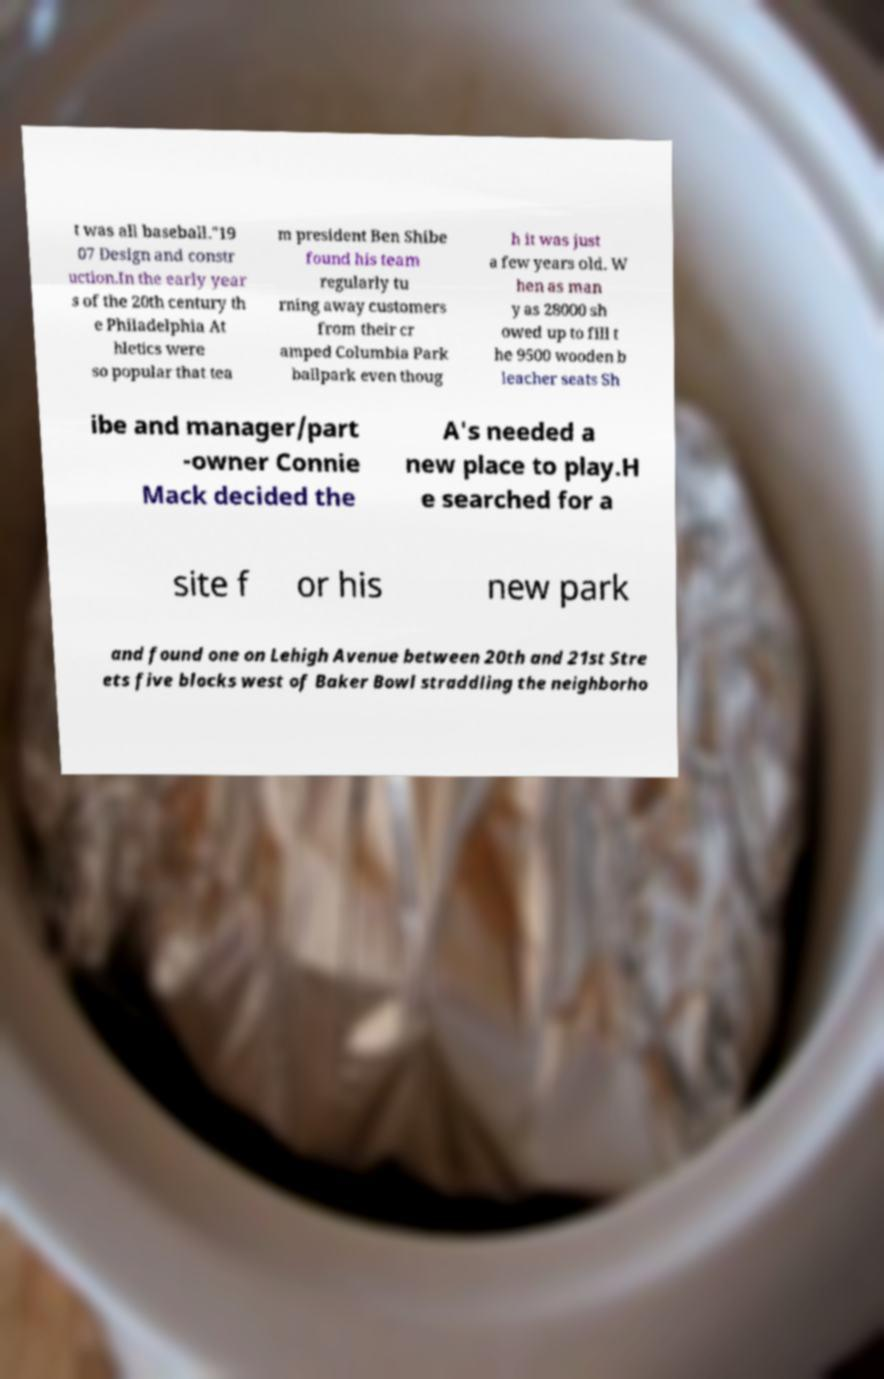Could you assist in decoding the text presented in this image and type it out clearly? t was all baseball."19 07 Design and constr uction.In the early year s of the 20th century th e Philadelphia At hletics were so popular that tea m president Ben Shibe found his team regularly tu rning away customers from their cr amped Columbia Park ballpark even thoug h it was just a few years old. W hen as man y as 28000 sh owed up to fill t he 9500 wooden b leacher seats Sh ibe and manager/part -owner Connie Mack decided the A's needed a new place to play.H e searched for a site f or his new park and found one on Lehigh Avenue between 20th and 21st Stre ets five blocks west of Baker Bowl straddling the neighborho 